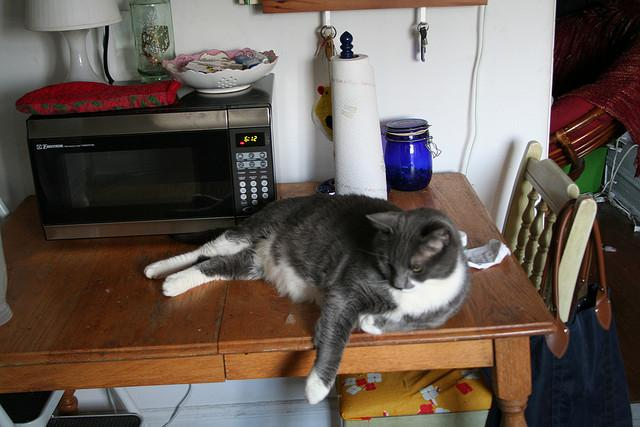What is illuminating the cat and the table?

Choices:
A) led light
B) halogen light
C) fluorescent light
D) sunlight sunlight 